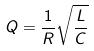<formula> <loc_0><loc_0><loc_500><loc_500>Q = \frac { 1 } { R } \sqrt { \frac { L } { C } }</formula> 